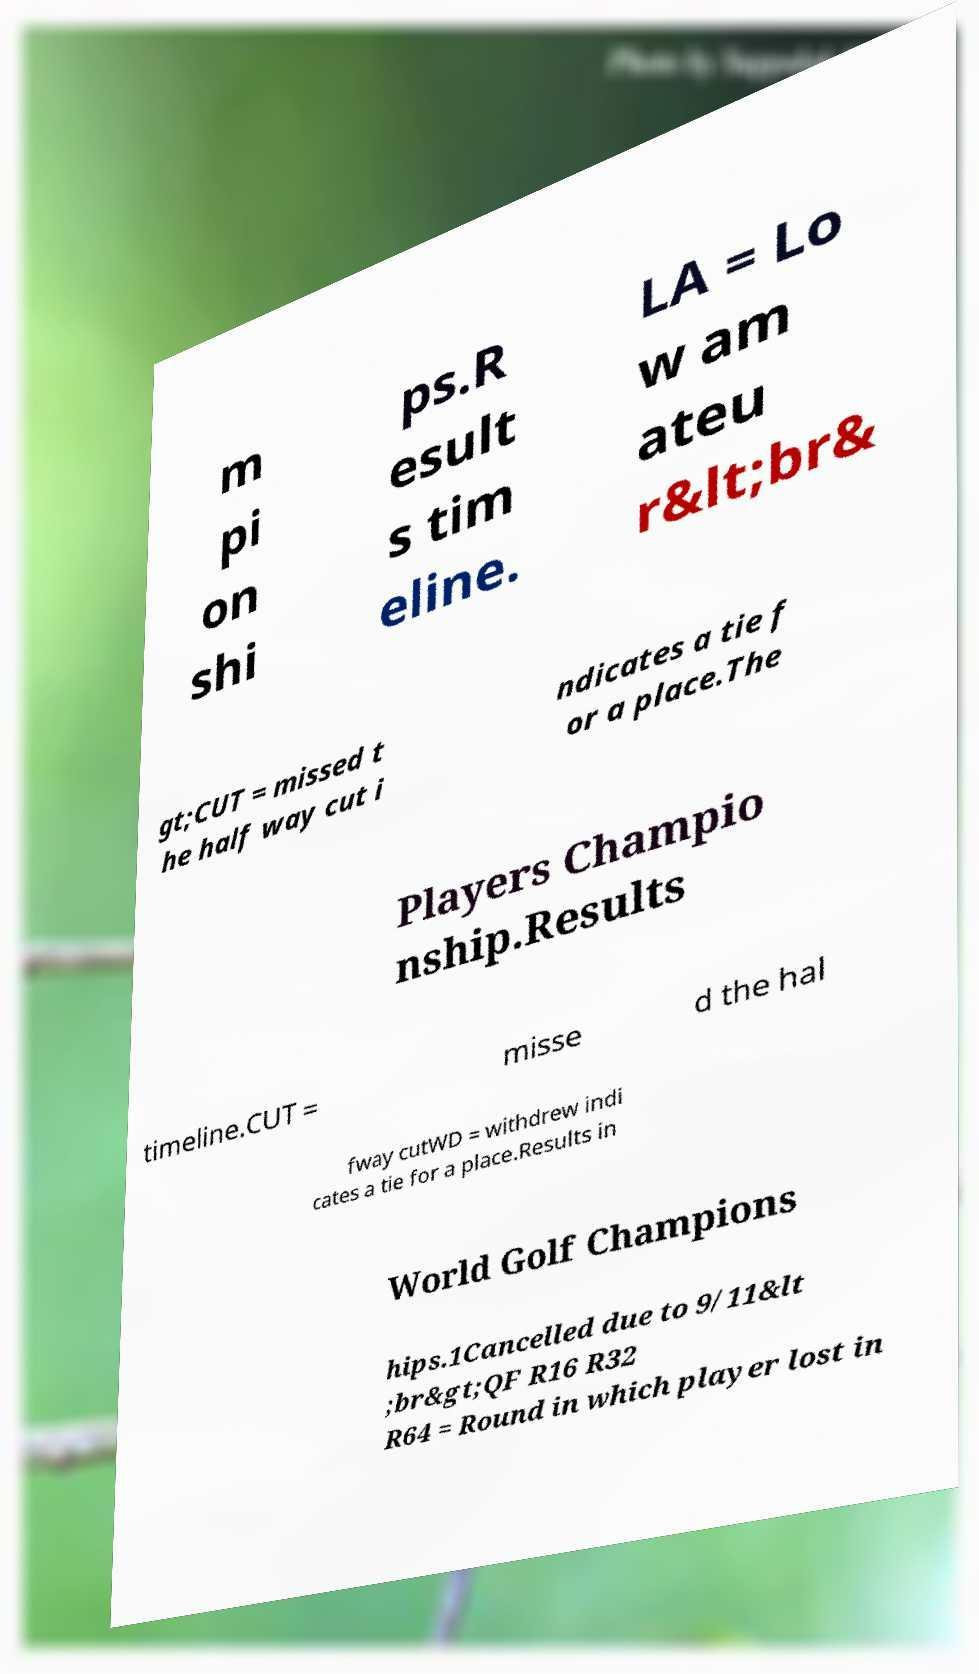Could you extract and type out the text from this image? m pi on shi ps.R esult s tim eline. LA = Lo w am ateu r&lt;br& gt;CUT = missed t he half way cut i ndicates a tie f or a place.The Players Champio nship.Results timeline.CUT = misse d the hal fway cutWD = withdrew indi cates a tie for a place.Results in World Golf Champions hips.1Cancelled due to 9/11&lt ;br&gt;QF R16 R32 R64 = Round in which player lost in 